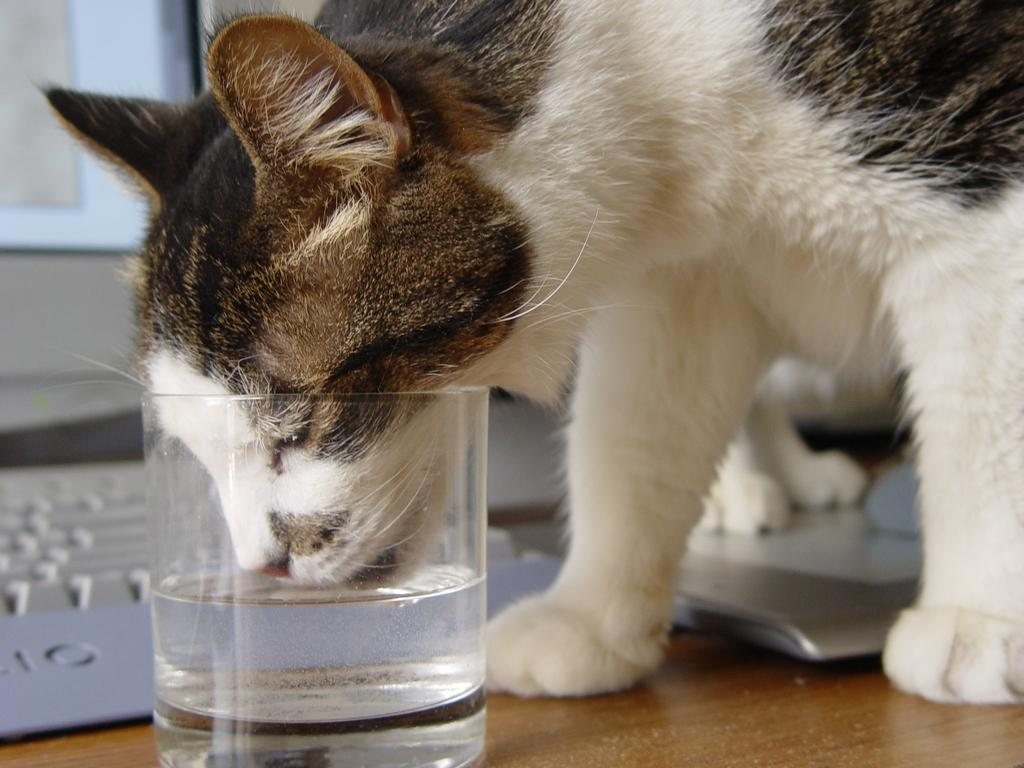What animal can be seen in the image? There is a cat in the image. What is the cat doing in the image? The cat is drinking water. How is the water being contained in the image? The water is in a glass. What electronic device is visible in the image? There is a laptop visible in the image. What verse is the cat reciting in the image? There is no verse being recited in the image, as the cat is drinking water from a glass. How many children are present in the image? There are no children present in the image; it features a cat drinking water from a glass and a laptop. 